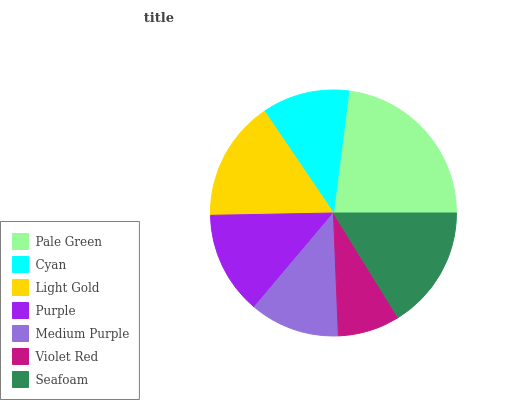Is Violet Red the minimum?
Answer yes or no. Yes. Is Pale Green the maximum?
Answer yes or no. Yes. Is Cyan the minimum?
Answer yes or no. No. Is Cyan the maximum?
Answer yes or no. No. Is Pale Green greater than Cyan?
Answer yes or no. Yes. Is Cyan less than Pale Green?
Answer yes or no. Yes. Is Cyan greater than Pale Green?
Answer yes or no. No. Is Pale Green less than Cyan?
Answer yes or no. No. Is Purple the high median?
Answer yes or no. Yes. Is Purple the low median?
Answer yes or no. Yes. Is Seafoam the high median?
Answer yes or no. No. Is Seafoam the low median?
Answer yes or no. No. 